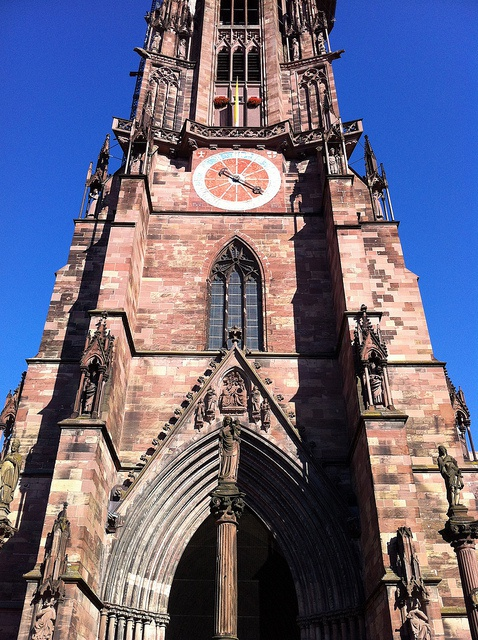Describe the objects in this image and their specific colors. I can see a clock in blue, white, salmon, and tan tones in this image. 